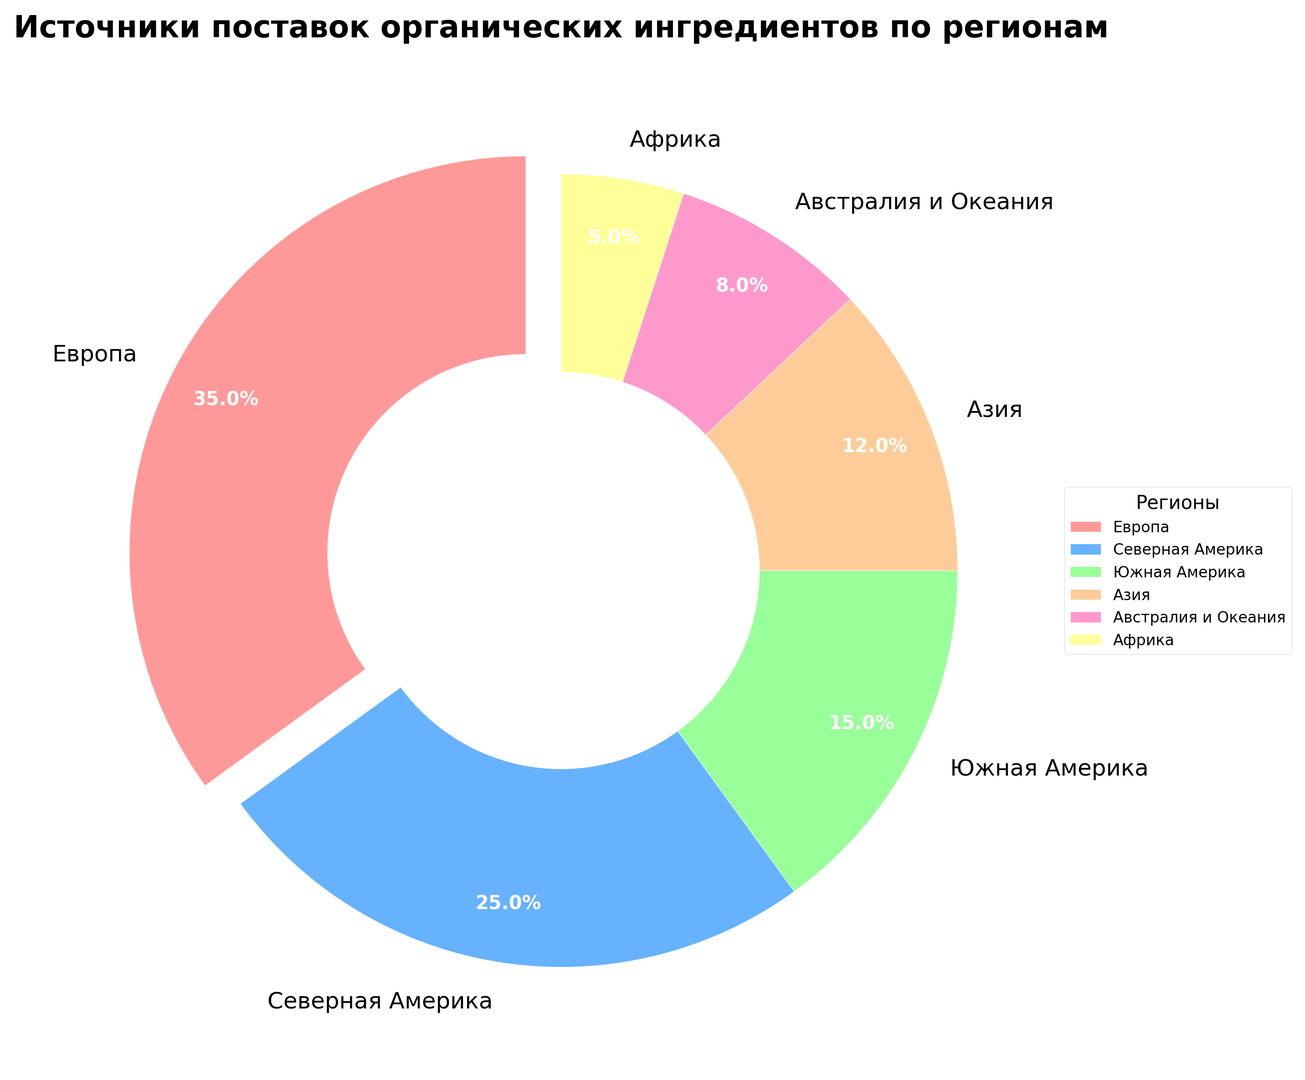Какой регион доминирует в поставках органических ингредиентов? Посмотрите на сектор, который выделяется по размеру, и его подпись. Европа занимает самую большую часть пирога и имеет взрыв на 10%.
Answer: Европа Какая часть поставок приходится на Африку? Обратите внимание на сектор, подписанный "Африка" и процентную метку внутри него. Африка занимает 5%.
Answer: 5% Чем отличается вклад Северной и Южной Америки? Найдите сектора, подписанные "Северная Америка" и "Южная Америка". Северная Америка составляет 25%, а Южная Америка – 15%. Разница составляет 10%.
Answer: 10% Сколько процентов поставок приходят из региона, который является третьим по величине? Найдите третий по величине сектор. Первый – Европа (35%), второй – Северная Америка (25%), третий – Южная Америка (15%).
Answer: 15% Какие два региона совместно составляют более половины всех поставок? Определите два крупнейших сектора – это Европа (35%) и Северная Америка (25%). В сумме они составляют 60%.
Answer: Европа и Северная Америка Какова суммарная доля поставок из азиатских и африканских регионов? Найдите сектора, подписанные "Азия" и "Африка". Сумма их вкладов – это 12% + 5% = 17%.
Answer: 17% Каков вклад региона, окрашенного зеленым цветом? Найдите сектор зеленого цвета и его подпись. Зеленым окрашен сектор Европы, который занимает 35%.
Answer: 35% Сколько регионов совместно составляют менее 20% поставок? Найдите все сектора, сумма которых составляет менее 20%. Это Австралия и Океания (8%) и Африка (5%), всего 13%, то есть два региона.
Answer: 2 Какой регион составляет меньше всего поставок? Обратите внимание на самый маленький сектор и его подпись. Африка занимает 5% и является самым маленьким сектором.
Answer: Африка 